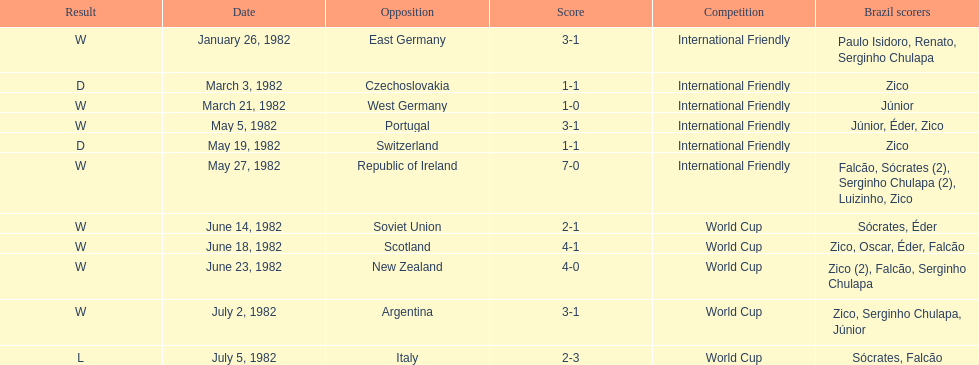How many times did brazil play west germany during the 1982 season? 1. 